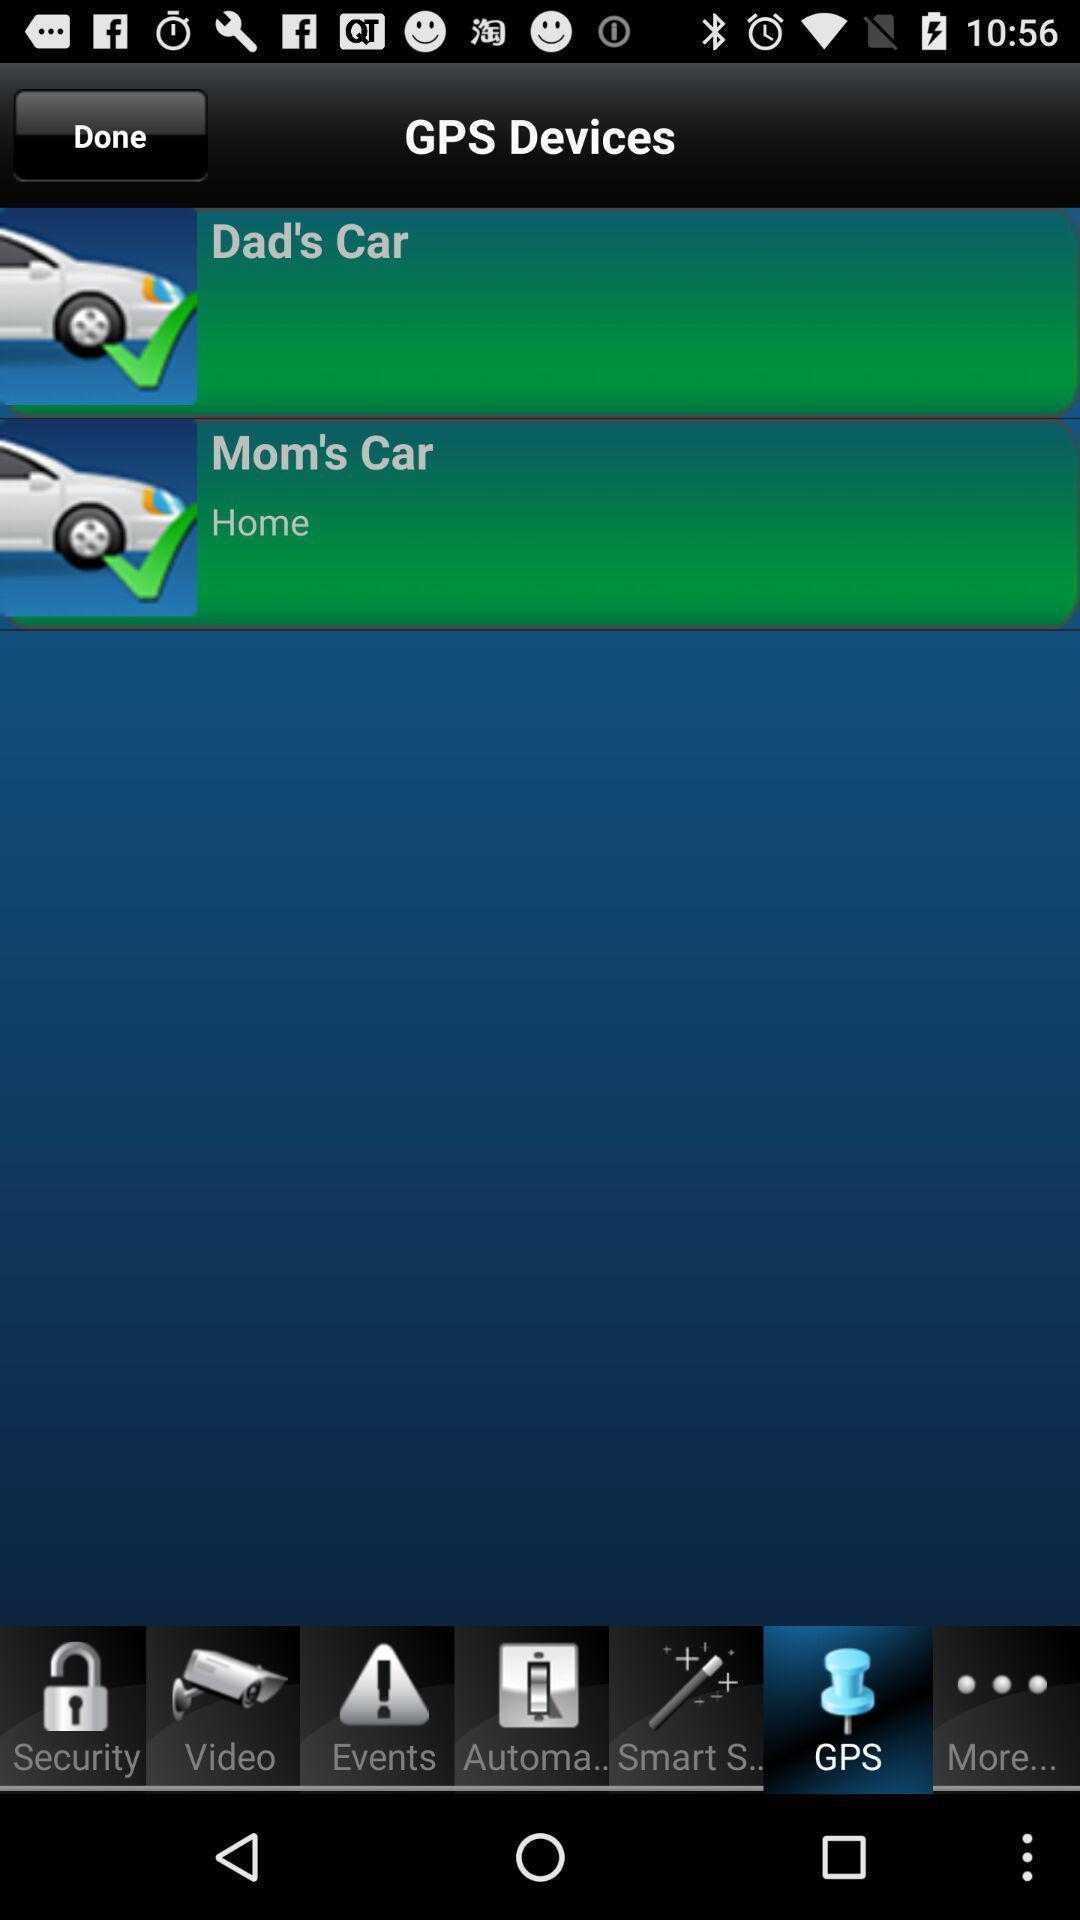Describe this image in words. Various gps tracking automobiles page displayed includes various options. 